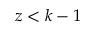Convert formula to latex. <formula><loc_0><loc_0><loc_500><loc_500>z < k - 1</formula> 